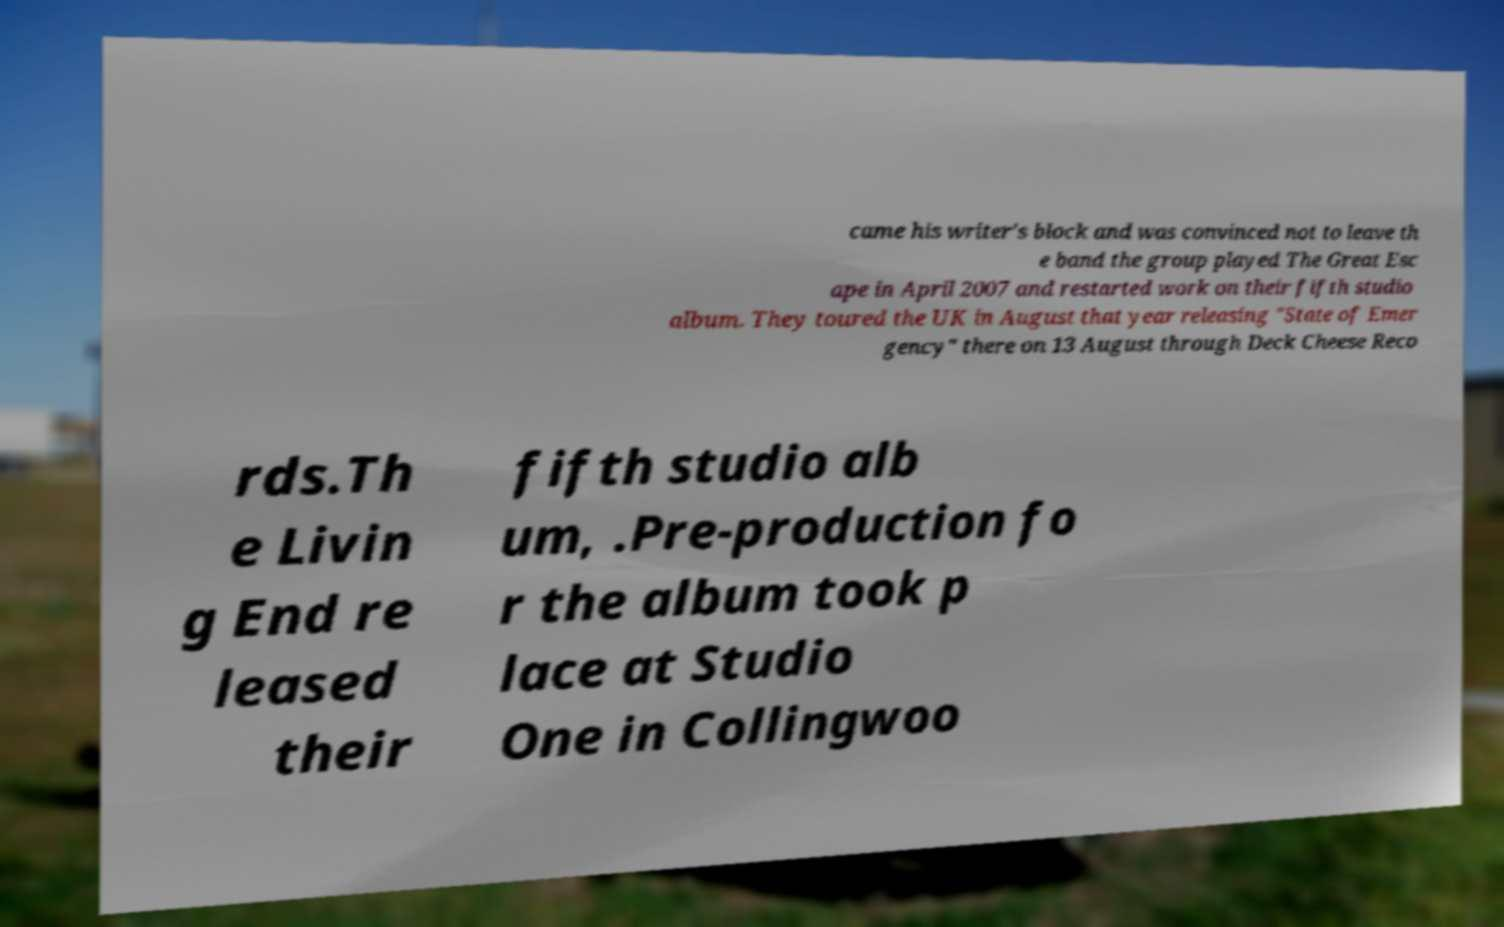Please identify and transcribe the text found in this image. came his writer's block and was convinced not to leave th e band the group played The Great Esc ape in April 2007 and restarted work on their fifth studio album. They toured the UK in August that year releasing "State of Emer gency" there on 13 August through Deck Cheese Reco rds.Th e Livin g End re leased their fifth studio alb um, .Pre-production fo r the album took p lace at Studio One in Collingwoo 